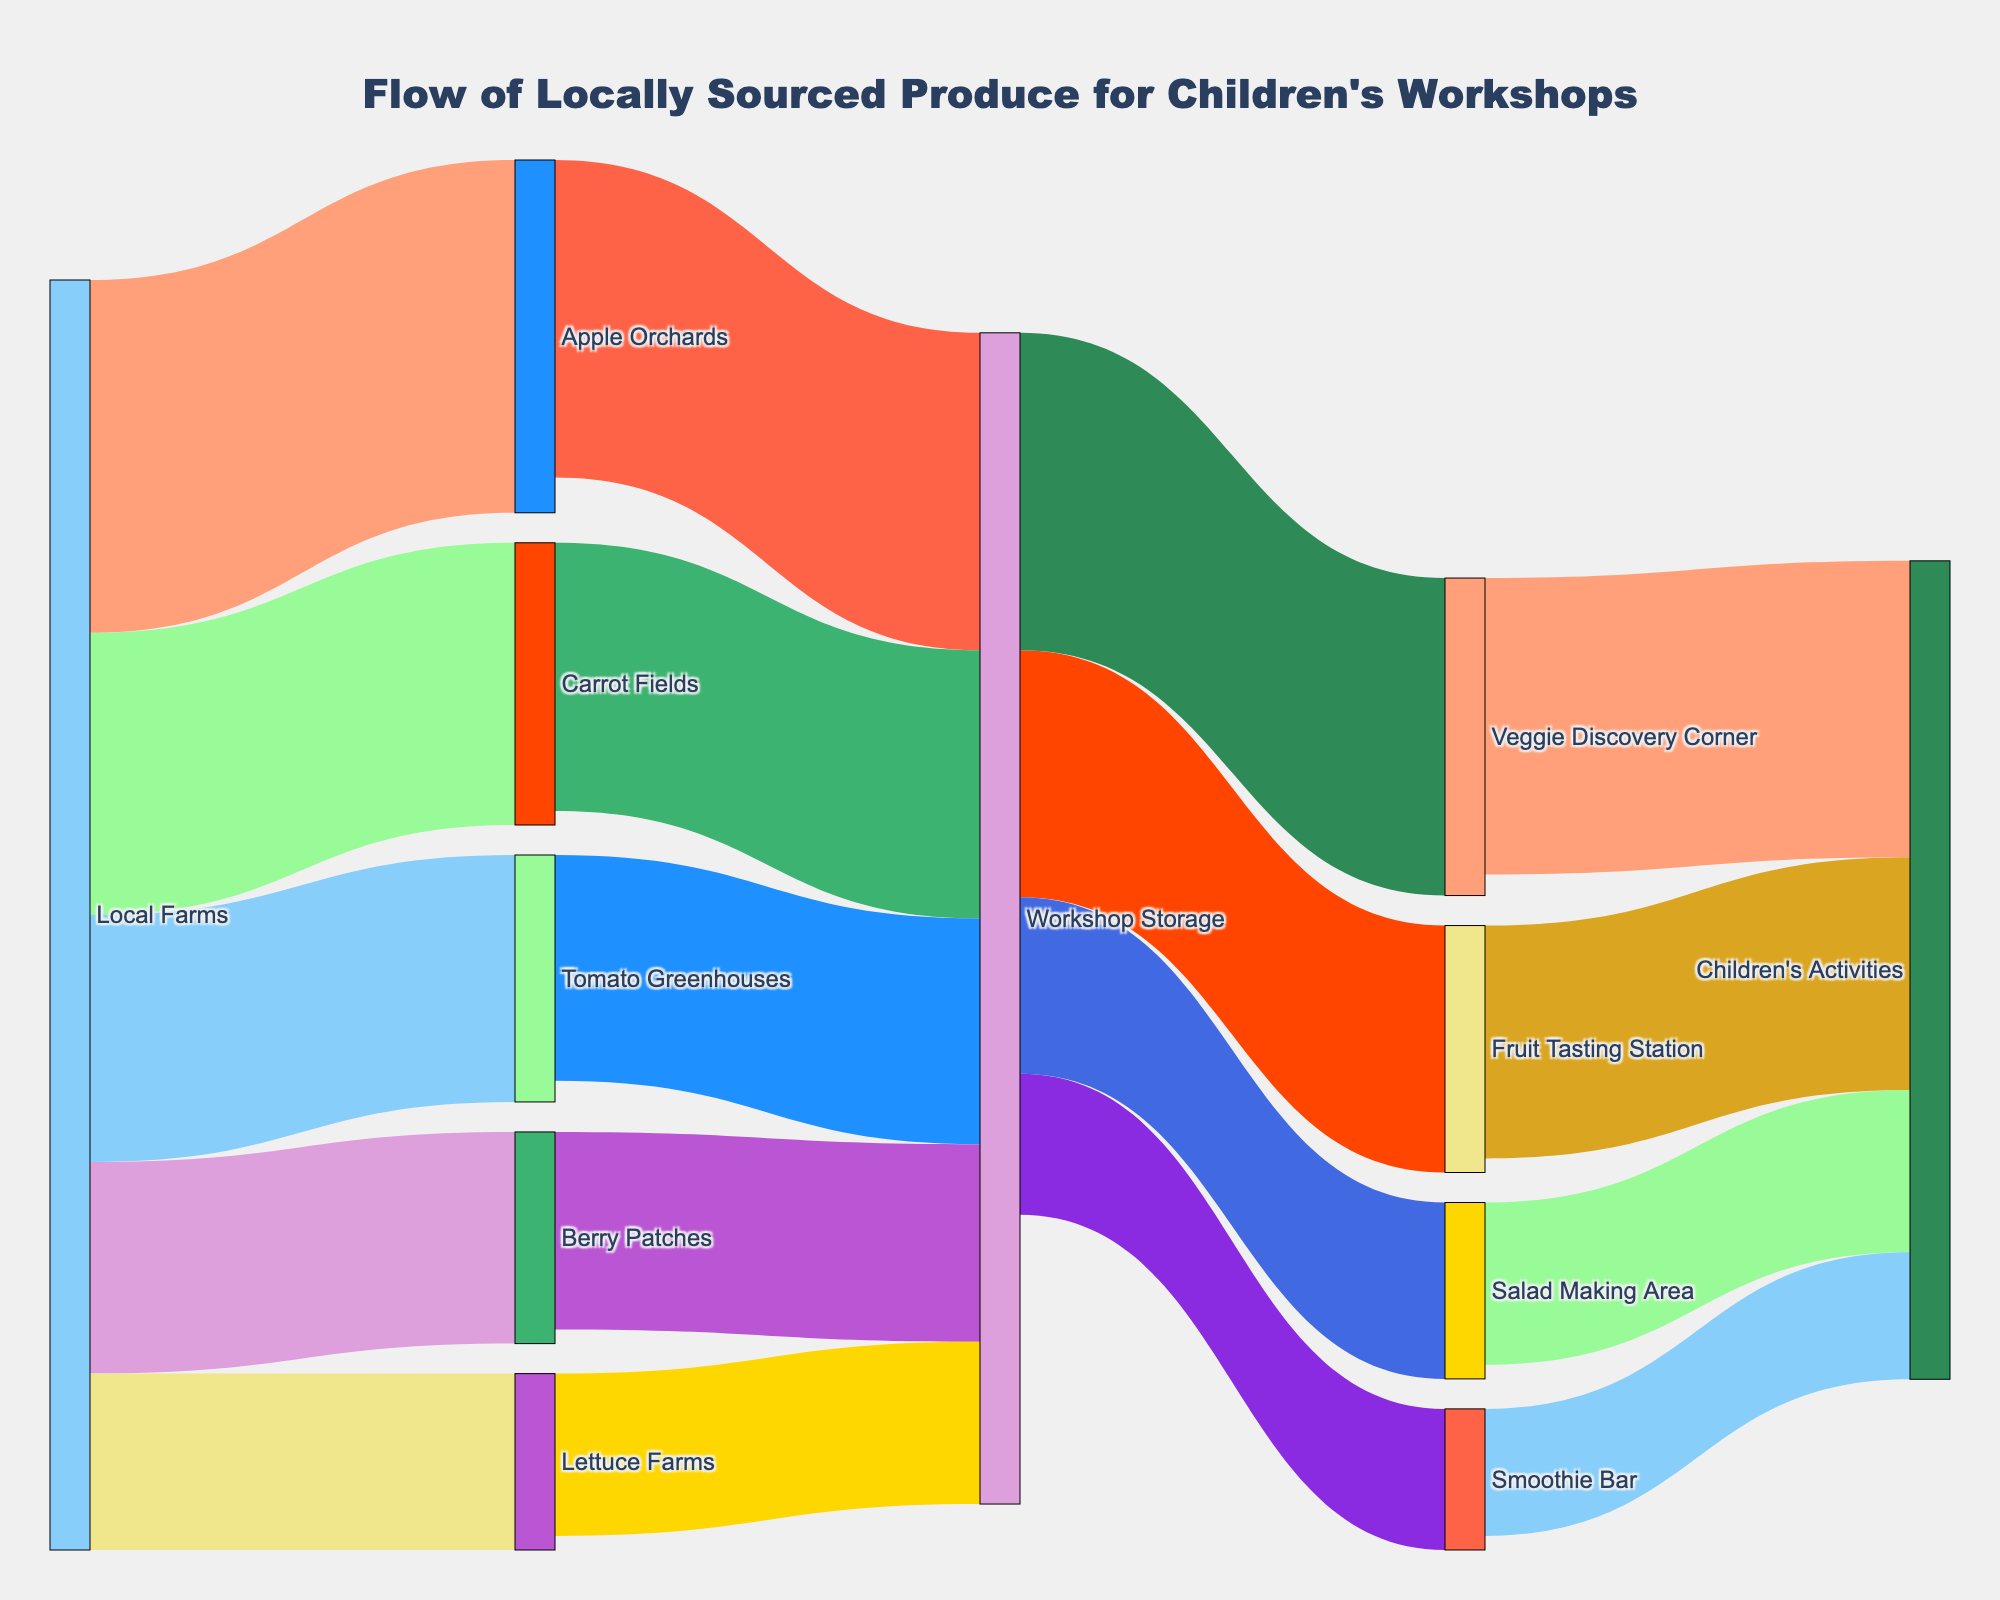What is the total flow of produce from Local Farms to Children's Activities? The flow from Local Farms to Children’s Activities can be calculated by summing the values through each route. Calculate the flow through each intermediate node (each value going from Local Farms to Workshop Storage and then from Workshop Storage to Children's Activities through the four final nodes). The total sum is: (50+40+35+30+25) + (45+38+32+28+23) = 150 from each primary node to Workshop Storage, and then from Workshop Storage to Children's Activities is 33+42+23+18 = 116. So total is 266.
Answer: 266 What fruit type has the highest value flowing from local farms? By comparing the values for each fruit type flowing from Local Farms, we see that the highest value is for Apple Orchards with a value of 50.
Answer: Apple Orchards How many types of flows are sent from Workshop Storage to its destinations? Workshop Storage sends flows to four different destinations: Fruit Tasting Station, Veggie Discovery Corner, Salad Making Area, and Smoothie Bar.
Answer: 4 Which station receives the most produce from Workshop Storage? By comparing the values flowing from Workshop Storage, the Veggie Discovery Corner receives the most with a flow of 45.
Answer: Veggie Discovery Corner What is the total flow of produce into Workshop Storage? The total flow into Workshop Storage is the sum of values from all sources flowing into it. By summing the values for each flow into Workshop Storage: (45 + 38 + 32 + 28 + 23), we get a total of 166.
Answer: 166 Which category has the smallest flow from Local Farms to Workshop Storage? Comparing the values flowing from Local Farms to Workshop Storage, the Lettuce Farms have the smallest flow at 23.
Answer: Lettuce Farms What percentage of the flow from Workshop Storage goes to the Smoothie Bar? The total flow from Workshop Storage is 166. The flow to Smoothie Bar is 20. The percentage is calculated as (20 / 166) * 100 ≈ 12.05%.
Answer: 12.05% If the flow to Children's Activities from Fruit Tasting Station is reduced by 10, what would be the new total flow into Children's Activities? The current total flow into Children's Activities is (33 + 42 + 23 + 18) = 116. If the flow from Fruit Tasting Station is reduced by 10, the new value becomes (33 - 10) + 42 + 23 + 18 = 106.
Answer: 106 